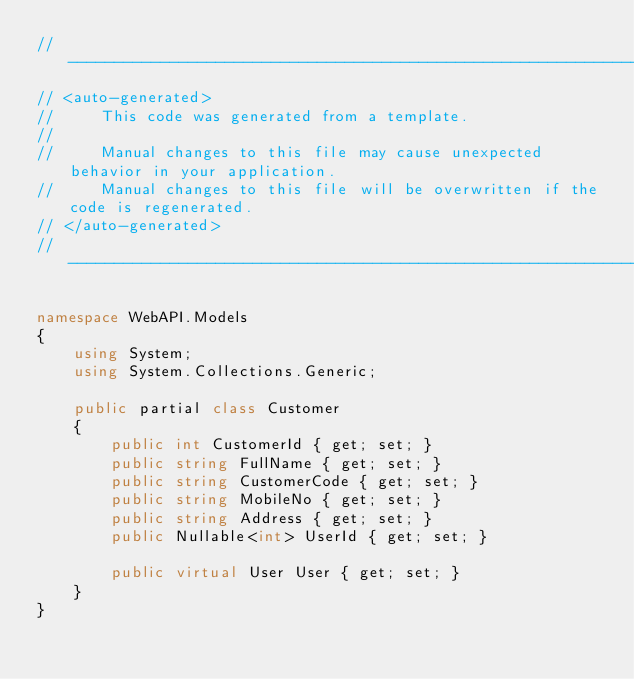<code> <loc_0><loc_0><loc_500><loc_500><_C#_>//------------------------------------------------------------------------------
// <auto-generated>
//     This code was generated from a template.
//
//     Manual changes to this file may cause unexpected behavior in your application.
//     Manual changes to this file will be overwritten if the code is regenerated.
// </auto-generated>
//------------------------------------------------------------------------------

namespace WebAPI.Models
{
    using System;
    using System.Collections.Generic;
    
    public partial class Customer
    {
        public int CustomerId { get; set; }
        public string FullName { get; set; }
        public string CustomerCode { get; set; }
        public string MobileNo { get; set; }
        public string Address { get; set; }
        public Nullable<int> UserId { get; set; }
    
        public virtual User User { get; set; }
    }
}
</code> 